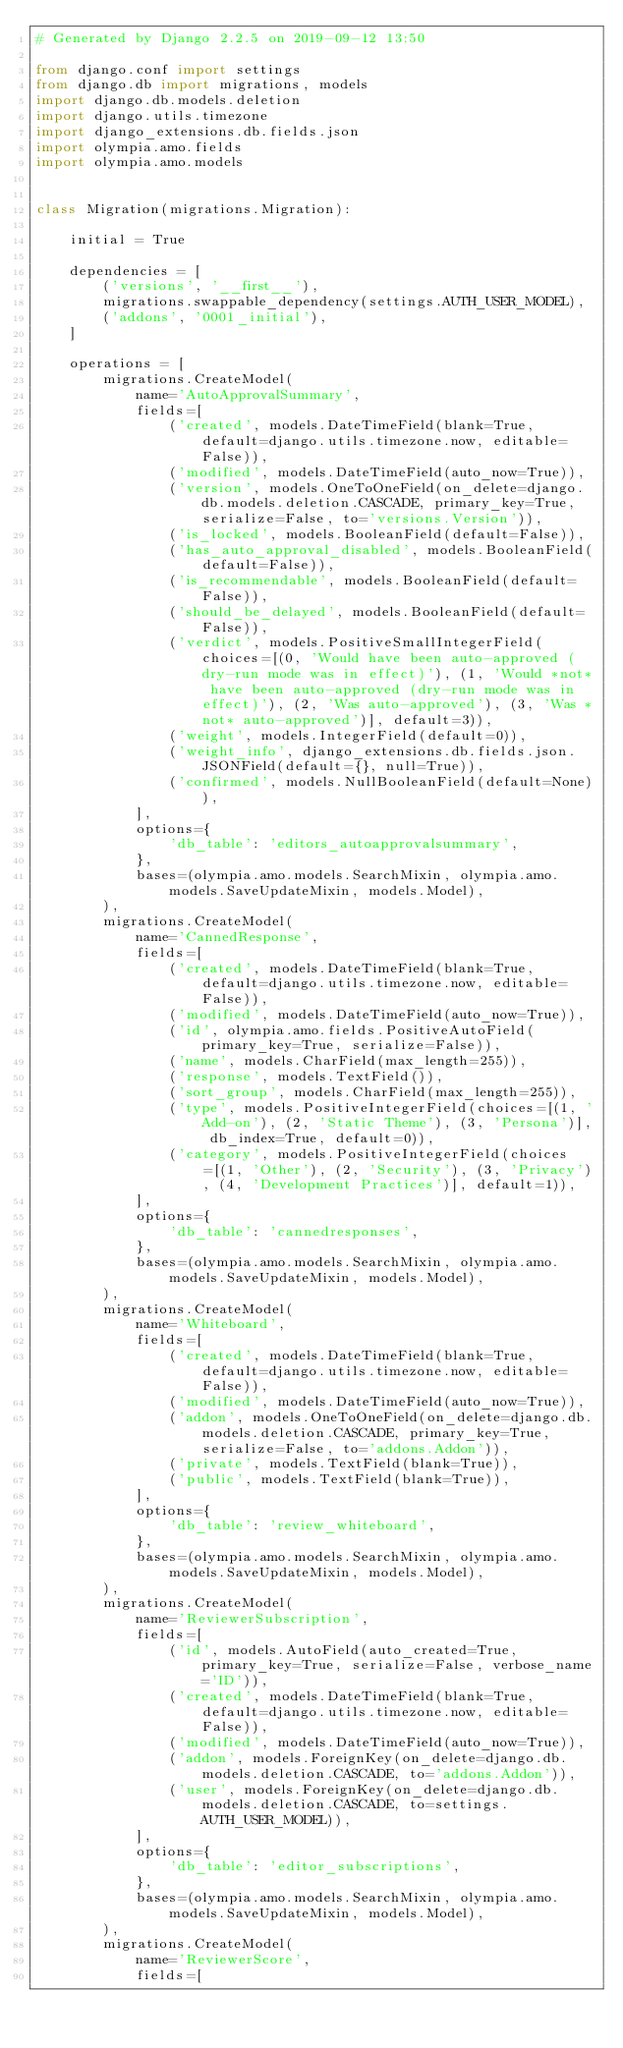Convert code to text. <code><loc_0><loc_0><loc_500><loc_500><_Python_># Generated by Django 2.2.5 on 2019-09-12 13:50

from django.conf import settings
from django.db import migrations, models
import django.db.models.deletion
import django.utils.timezone
import django_extensions.db.fields.json
import olympia.amo.fields
import olympia.amo.models


class Migration(migrations.Migration):

    initial = True

    dependencies = [
        ('versions', '__first__'),
        migrations.swappable_dependency(settings.AUTH_USER_MODEL),
        ('addons', '0001_initial'),
    ]

    operations = [
        migrations.CreateModel(
            name='AutoApprovalSummary',
            fields=[
                ('created', models.DateTimeField(blank=True, default=django.utils.timezone.now, editable=False)),
                ('modified', models.DateTimeField(auto_now=True)),
                ('version', models.OneToOneField(on_delete=django.db.models.deletion.CASCADE, primary_key=True, serialize=False, to='versions.Version')),
                ('is_locked', models.BooleanField(default=False)),
                ('has_auto_approval_disabled', models.BooleanField(default=False)),
                ('is_recommendable', models.BooleanField(default=False)),
                ('should_be_delayed', models.BooleanField(default=False)),
                ('verdict', models.PositiveSmallIntegerField(choices=[(0, 'Would have been auto-approved (dry-run mode was in effect)'), (1, 'Would *not* have been auto-approved (dry-run mode was in effect)'), (2, 'Was auto-approved'), (3, 'Was *not* auto-approved')], default=3)),
                ('weight', models.IntegerField(default=0)),
                ('weight_info', django_extensions.db.fields.json.JSONField(default={}, null=True)),
                ('confirmed', models.NullBooleanField(default=None)),
            ],
            options={
                'db_table': 'editors_autoapprovalsummary',
            },
            bases=(olympia.amo.models.SearchMixin, olympia.amo.models.SaveUpdateMixin, models.Model),
        ),
        migrations.CreateModel(
            name='CannedResponse',
            fields=[
                ('created', models.DateTimeField(blank=True, default=django.utils.timezone.now, editable=False)),
                ('modified', models.DateTimeField(auto_now=True)),
                ('id', olympia.amo.fields.PositiveAutoField(primary_key=True, serialize=False)),
                ('name', models.CharField(max_length=255)),
                ('response', models.TextField()),
                ('sort_group', models.CharField(max_length=255)),
                ('type', models.PositiveIntegerField(choices=[(1, 'Add-on'), (2, 'Static Theme'), (3, 'Persona')], db_index=True, default=0)),
                ('category', models.PositiveIntegerField(choices=[(1, 'Other'), (2, 'Security'), (3, 'Privacy'), (4, 'Development Practices')], default=1)),
            ],
            options={
                'db_table': 'cannedresponses',
            },
            bases=(olympia.amo.models.SearchMixin, olympia.amo.models.SaveUpdateMixin, models.Model),
        ),
        migrations.CreateModel(
            name='Whiteboard',
            fields=[
                ('created', models.DateTimeField(blank=True, default=django.utils.timezone.now, editable=False)),
                ('modified', models.DateTimeField(auto_now=True)),
                ('addon', models.OneToOneField(on_delete=django.db.models.deletion.CASCADE, primary_key=True, serialize=False, to='addons.Addon')),
                ('private', models.TextField(blank=True)),
                ('public', models.TextField(blank=True)),
            ],
            options={
                'db_table': 'review_whiteboard',
            },
            bases=(olympia.amo.models.SearchMixin, olympia.amo.models.SaveUpdateMixin, models.Model),
        ),
        migrations.CreateModel(
            name='ReviewerSubscription',
            fields=[
                ('id', models.AutoField(auto_created=True, primary_key=True, serialize=False, verbose_name='ID')),
                ('created', models.DateTimeField(blank=True, default=django.utils.timezone.now, editable=False)),
                ('modified', models.DateTimeField(auto_now=True)),
                ('addon', models.ForeignKey(on_delete=django.db.models.deletion.CASCADE, to='addons.Addon')),
                ('user', models.ForeignKey(on_delete=django.db.models.deletion.CASCADE, to=settings.AUTH_USER_MODEL)),
            ],
            options={
                'db_table': 'editor_subscriptions',
            },
            bases=(olympia.amo.models.SearchMixin, olympia.amo.models.SaveUpdateMixin, models.Model),
        ),
        migrations.CreateModel(
            name='ReviewerScore',
            fields=[</code> 